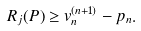<formula> <loc_0><loc_0><loc_500><loc_500>R _ { j } ( P ) \geq v _ { n } ^ { ( n + 1 ) } - p _ { n } .</formula> 